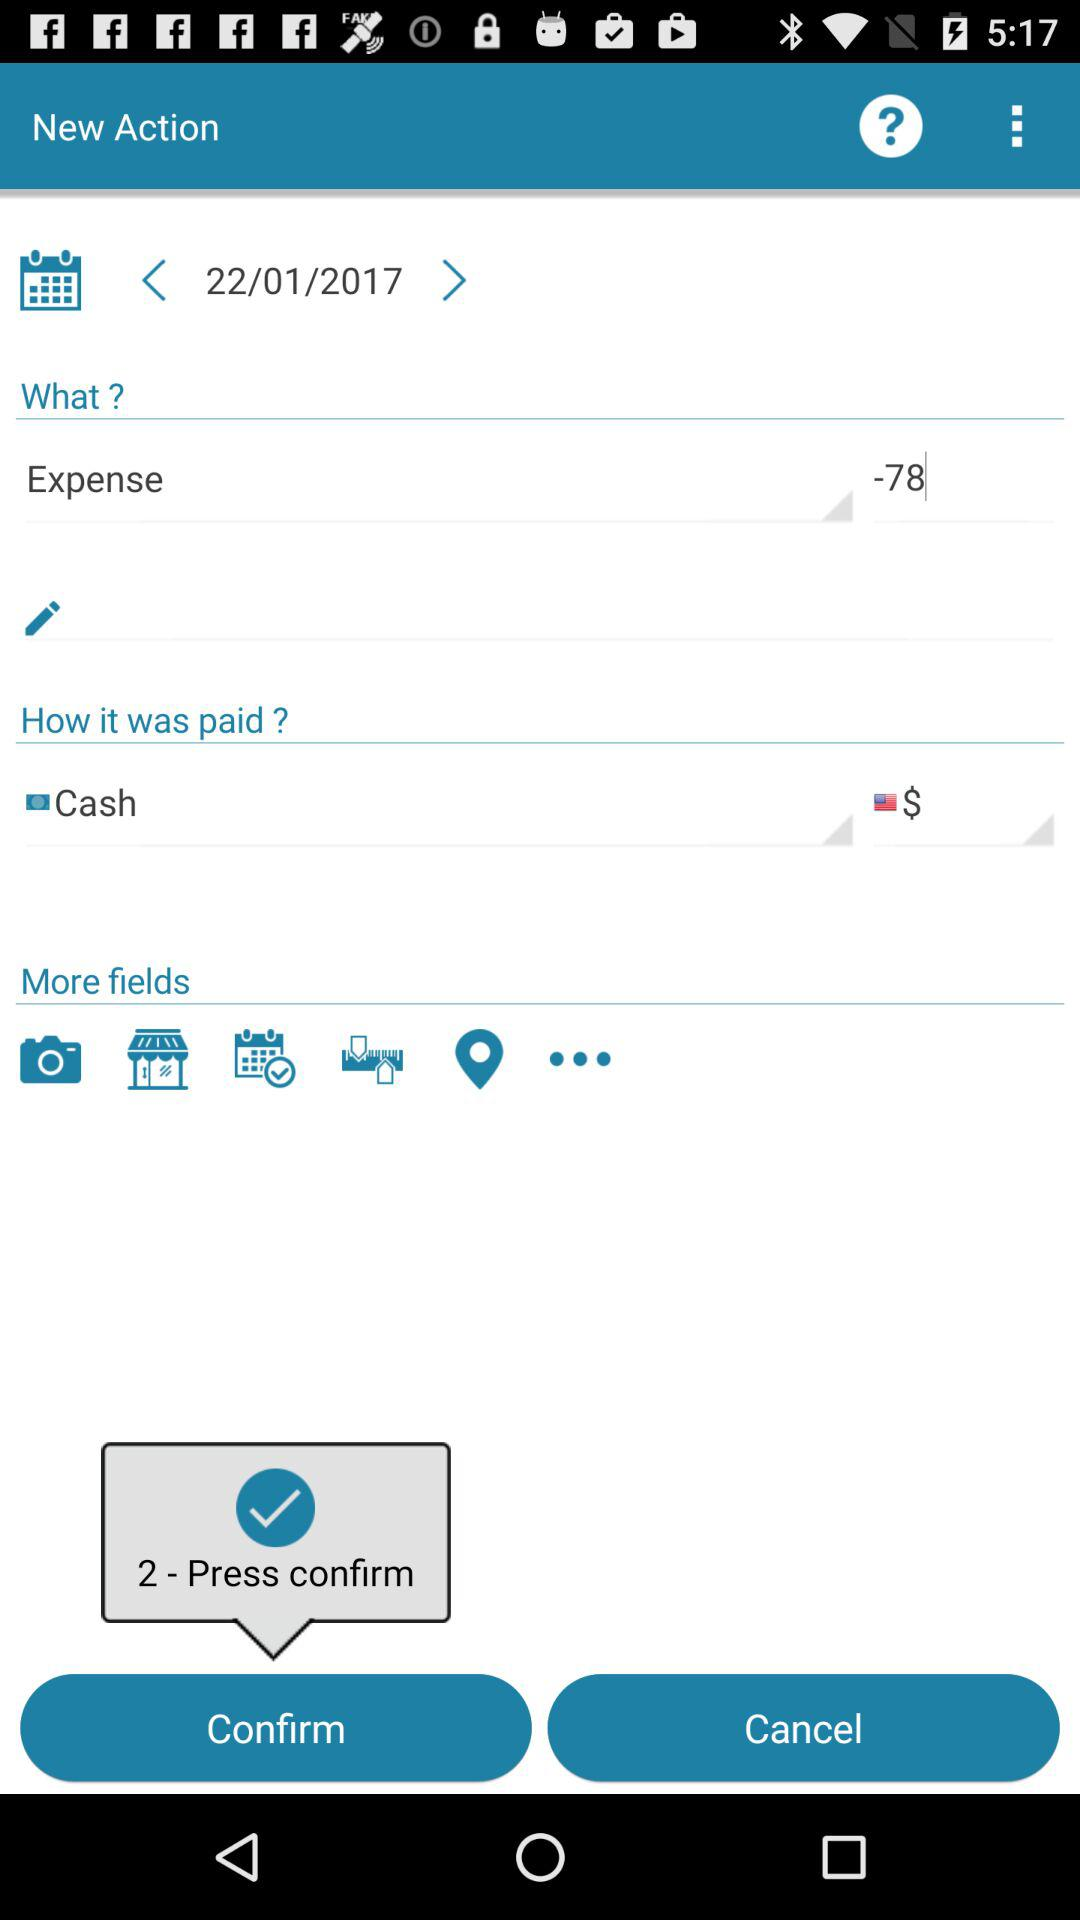What is the expense amount? The expense amount is 78. 